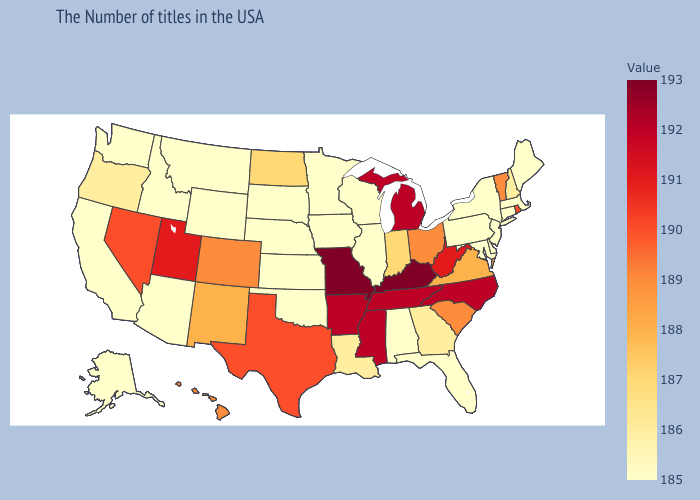Which states hav the highest value in the South?
Quick response, please. Kentucky. Does Utah have a higher value than Arkansas?
Write a very short answer. No. Does Texas have a higher value than Utah?
Concise answer only. No. Does the map have missing data?
Keep it brief. No. Does South Carolina have the lowest value in the USA?
Give a very brief answer. No. Among the states that border Vermont , does Massachusetts have the highest value?
Give a very brief answer. No. Among the states that border Mississippi , does Alabama have the lowest value?
Be succinct. Yes. Among the states that border Missouri , does Kentucky have the lowest value?
Quick response, please. No. 